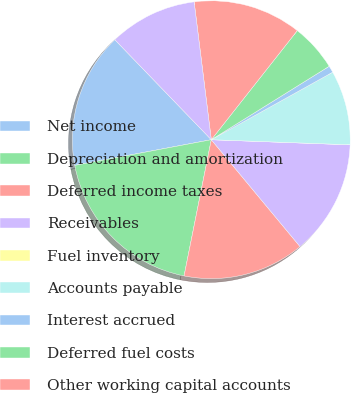Convert chart to OTSL. <chart><loc_0><loc_0><loc_500><loc_500><pie_chart><fcel>Net income<fcel>Depreciation and amortization<fcel>Deferred income taxes<fcel>Receivables<fcel>Fuel inventory<fcel>Accounts payable<fcel>Interest accrued<fcel>Deferred fuel costs<fcel>Other working capital accounts<fcel>Provisions for estimated<nl><fcel>15.75%<fcel>18.9%<fcel>14.17%<fcel>13.39%<fcel>0.0%<fcel>8.66%<fcel>0.79%<fcel>5.51%<fcel>12.6%<fcel>10.24%<nl></chart> 